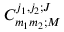Convert formula to latex. <formula><loc_0><loc_0><loc_500><loc_500>C _ { m _ { 1 } m _ { 2 } ; M } ^ { j _ { 1 } , j _ { 2 } ; J }</formula> 